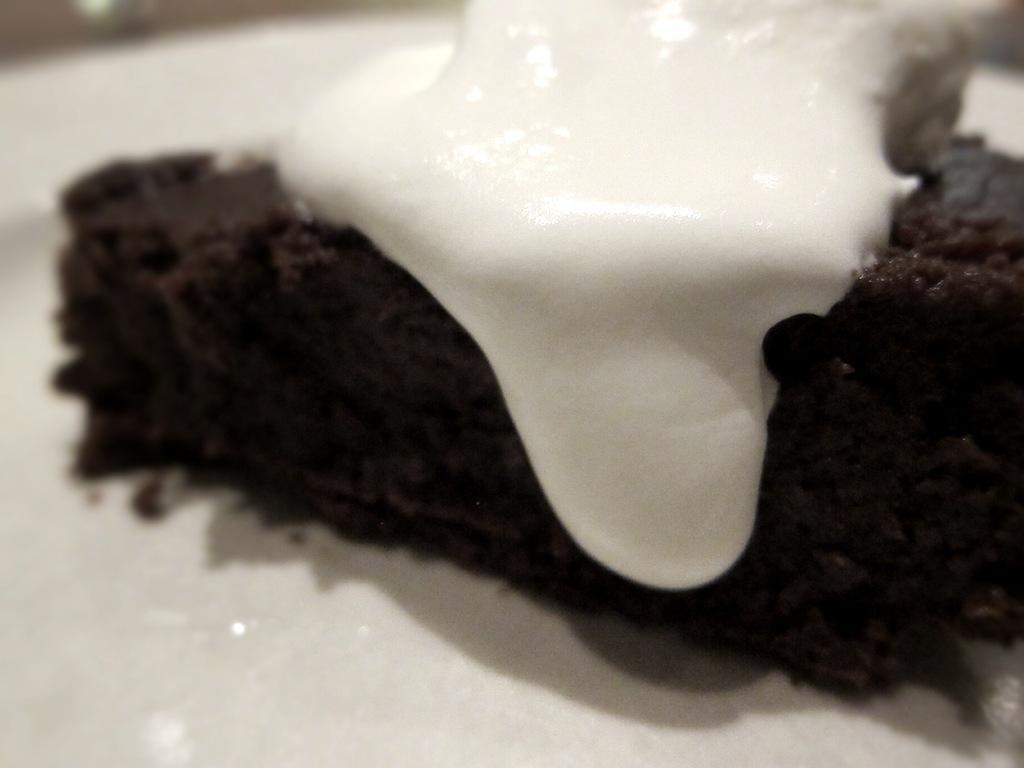How would you summarize this image in a sentence or two? In the foreground of this picture, there is a chocolate cake on which ice cream is present on a platter. 